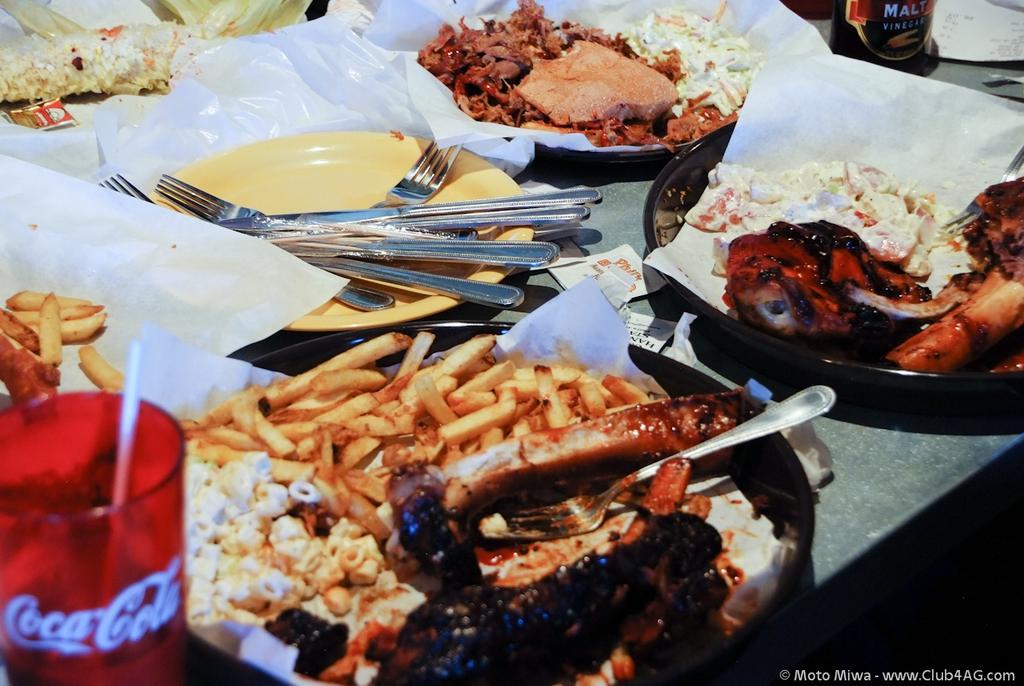Can you describe this image briefly? In this image we can see the food items placed on the plates. We can also see the foil, bottle, spoons and forks and on the left there is a coco cola glass with a straw and these items are placed on the table. In the bottom right corner there is text. 